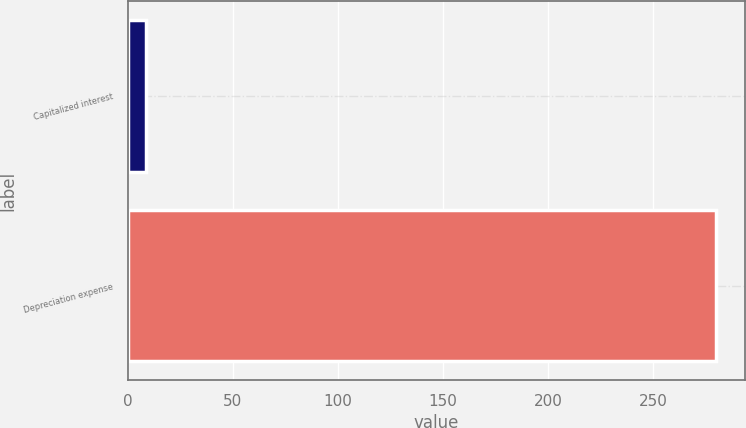Convert chart. <chart><loc_0><loc_0><loc_500><loc_500><bar_chart><fcel>Capitalized interest<fcel>Depreciation expense<nl><fcel>9<fcel>280<nl></chart> 